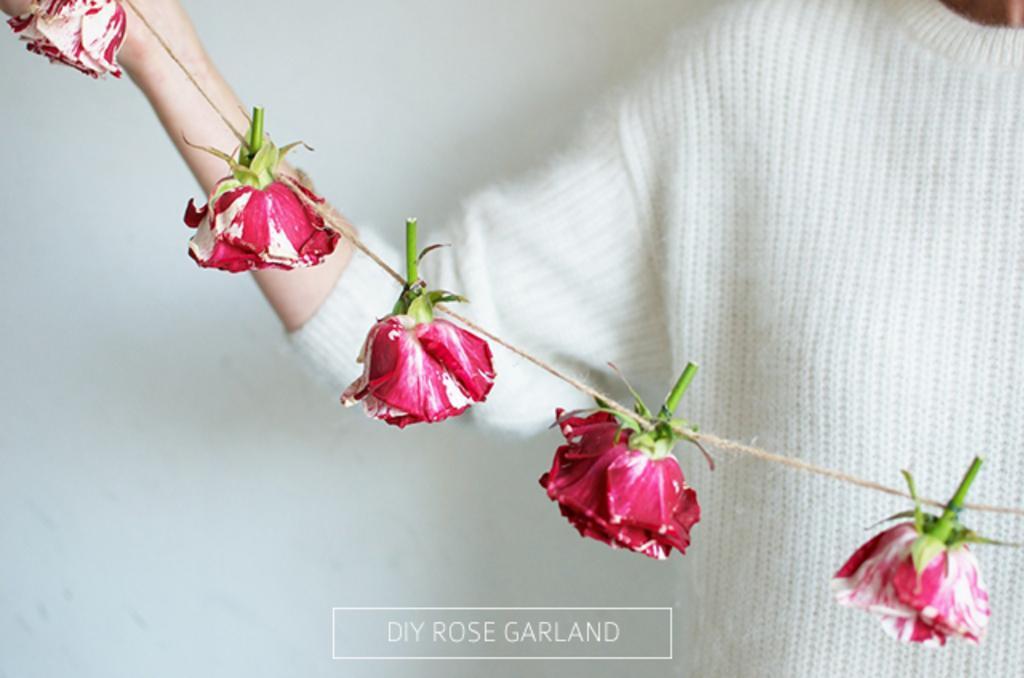How would you summarize this image in a sentence or two? This is a zoomed in picture. On the right there is a person wearing white color t-shirt, holding a garland of red roses. In the background there is a white color wall. At the bottom there is a text on the image. 